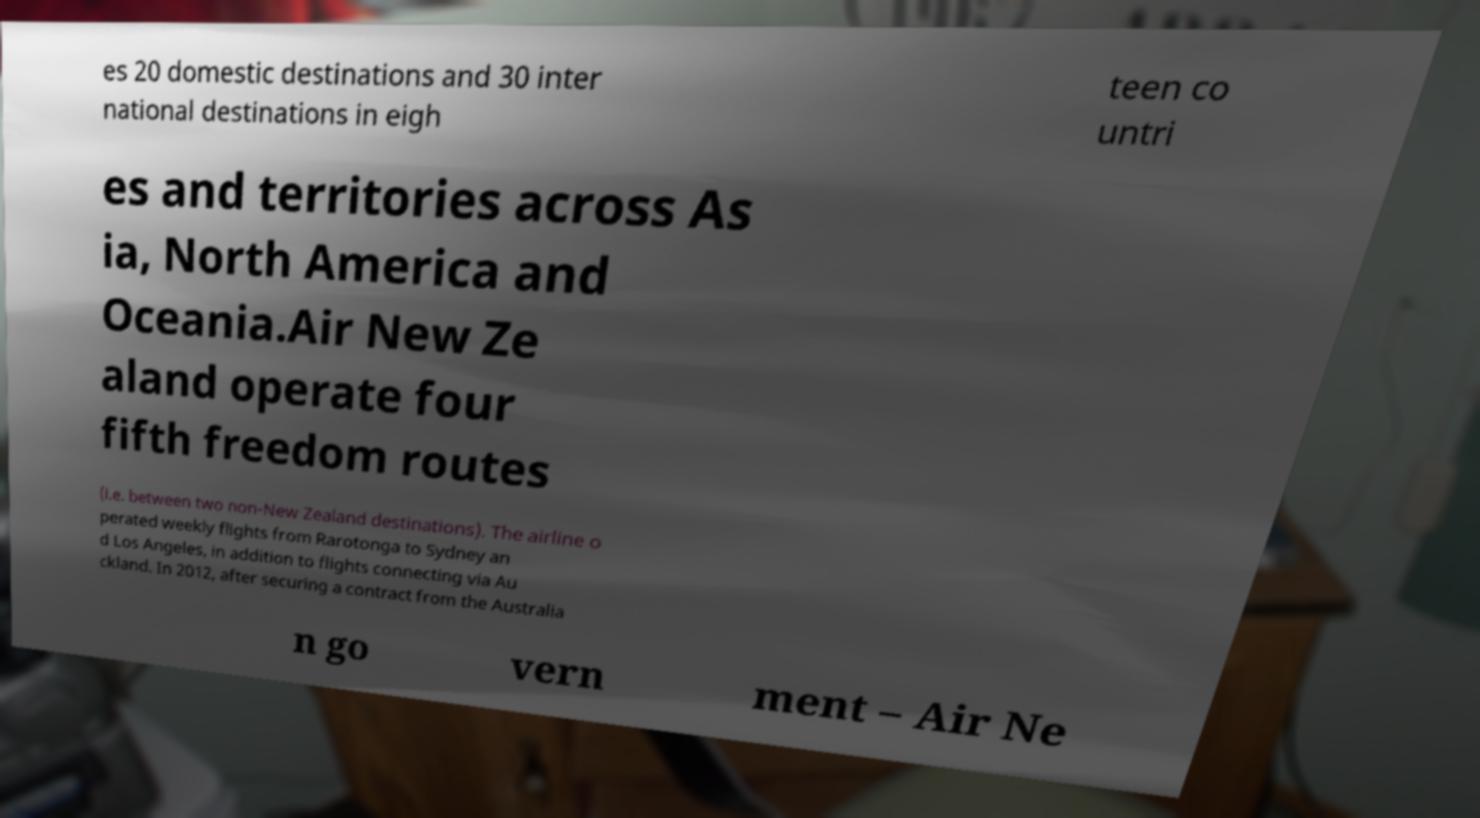What messages or text are displayed in this image? I need them in a readable, typed format. es 20 domestic destinations and 30 inter national destinations in eigh teen co untri es and territories across As ia, North America and Oceania.Air New Ze aland operate four fifth freedom routes (i.e. between two non-New Zealand destinations). The airline o perated weekly flights from Rarotonga to Sydney an d Los Angeles, in addition to flights connecting via Au ckland. In 2012, after securing a contract from the Australia n go vern ment – Air Ne 